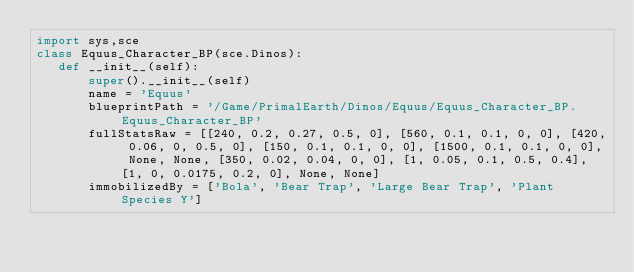<code> <loc_0><loc_0><loc_500><loc_500><_Python_>import sys,sce
class Equus_Character_BP(sce.Dinos):
   def __init__(self):
       super().__init__(self)
       name = 'Equus'
       blueprintPath = '/Game/PrimalEarth/Dinos/Equus/Equus_Character_BP.Equus_Character_BP'
       fullStatsRaw = [[240, 0.2, 0.27, 0.5, 0], [560, 0.1, 0.1, 0, 0], [420, 0.06, 0, 0.5, 0], [150, 0.1, 0.1, 0, 0], [1500, 0.1, 0.1, 0, 0], None, None, [350, 0.02, 0.04, 0, 0], [1, 0.05, 0.1, 0.5, 0.4], [1, 0, 0.0175, 0.2, 0], None, None]
       immobilizedBy = ['Bola', 'Bear Trap', 'Large Bear Trap', 'Plant Species Y']</code> 